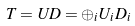Convert formula to latex. <formula><loc_0><loc_0><loc_500><loc_500>T = U D = \oplus _ { i } U _ { i } D _ { i }</formula> 